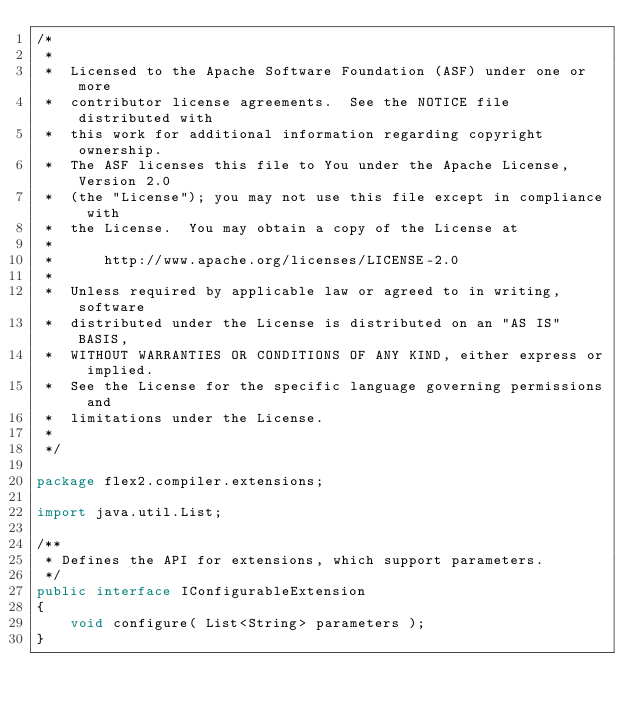<code> <loc_0><loc_0><loc_500><loc_500><_Java_>/*
 *
 *  Licensed to the Apache Software Foundation (ASF) under one or more
 *  contributor license agreements.  See the NOTICE file distributed with
 *  this work for additional information regarding copyright ownership.
 *  The ASF licenses this file to You under the Apache License, Version 2.0
 *  (the "License"); you may not use this file except in compliance with
 *  the License.  You may obtain a copy of the License at
 *
 *      http://www.apache.org/licenses/LICENSE-2.0
 *
 *  Unless required by applicable law or agreed to in writing, software
 *  distributed under the License is distributed on an "AS IS" BASIS,
 *  WITHOUT WARRANTIES OR CONDITIONS OF ANY KIND, either express or implied.
 *  See the License for the specific language governing permissions and
 *  limitations under the License.
 *
 */

package flex2.compiler.extensions;

import java.util.List;

/**
 * Defines the API for extensions, which support parameters.
 */
public interface IConfigurableExtension
{
    void configure( List<String> parameters );
}
</code> 